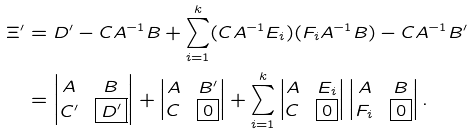Convert formula to latex. <formula><loc_0><loc_0><loc_500><loc_500>\Xi ^ { \prime } & = D ^ { \prime } - C A ^ { - 1 } B + \sum _ { i = 1 } ^ { k } ( C A ^ { - 1 } E _ { i } ) ( F _ { i } A ^ { - 1 } B ) - C A ^ { - 1 } B ^ { \prime } \\ & = \begin{vmatrix} A & B \\ C ^ { \prime } & \boxed { D ^ { \prime } } \end{vmatrix} + \begin{vmatrix} A & B ^ { \prime } \\ C & \boxed { 0 } \end{vmatrix} + \sum _ { i = 1 } ^ { k } \begin{vmatrix} A & E _ { i } \\ C & \boxed { 0 } \end{vmatrix} \begin{vmatrix} A & B \\ F _ { i } & \boxed { 0 } \end{vmatrix} .</formula> 